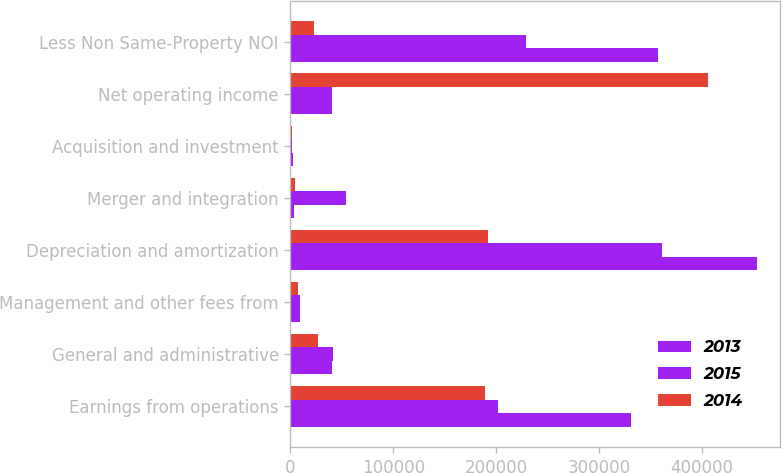Convert chart. <chart><loc_0><loc_0><loc_500><loc_500><stacked_bar_chart><ecel><fcel>Earnings from operations<fcel>General and administrative<fcel>Management and other fees from<fcel>Depreciation and amortization<fcel>Merger and integration<fcel>Acquisition and investment<fcel>Net operating income<fcel>Less Non Same-Property NOI<nl><fcel>2013<fcel>331174<fcel>40090<fcel>8909<fcel>453423<fcel>3798<fcel>2414<fcel>40484<fcel>357457<nl><fcel>2015<fcel>201514<fcel>40878<fcel>9347<fcel>360592<fcel>53530<fcel>1878<fcel>40484<fcel>229244<nl><fcel>2014<fcel>188705<fcel>26684<fcel>7263<fcel>192420<fcel>4284<fcel>1161<fcel>405991<fcel>22599<nl></chart> 